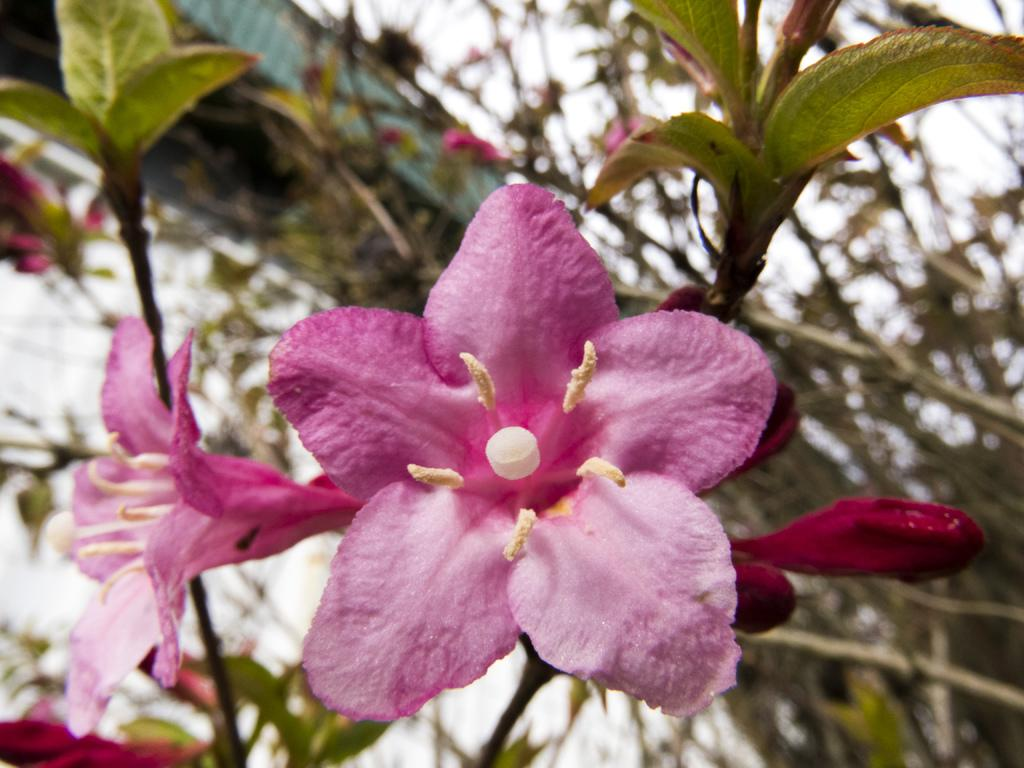What type of flowers are in the middle of the image? There are pink color flowers in the middle of the image. What else can be seen in the background of the image? There are plants in the background of the image. What invention can be seen in the image? There is no invention present in the image; it features flowers and plants. Are there any cobwebs visible in the image? There are no cobwebs present in the image. 